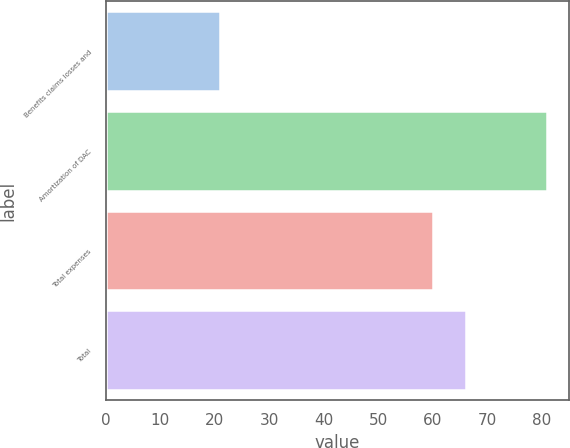<chart> <loc_0><loc_0><loc_500><loc_500><bar_chart><fcel>Benefits claims losses and<fcel>Amortization of DAC<fcel>Total expenses<fcel>Total<nl><fcel>21<fcel>81<fcel>60<fcel>66<nl></chart> 